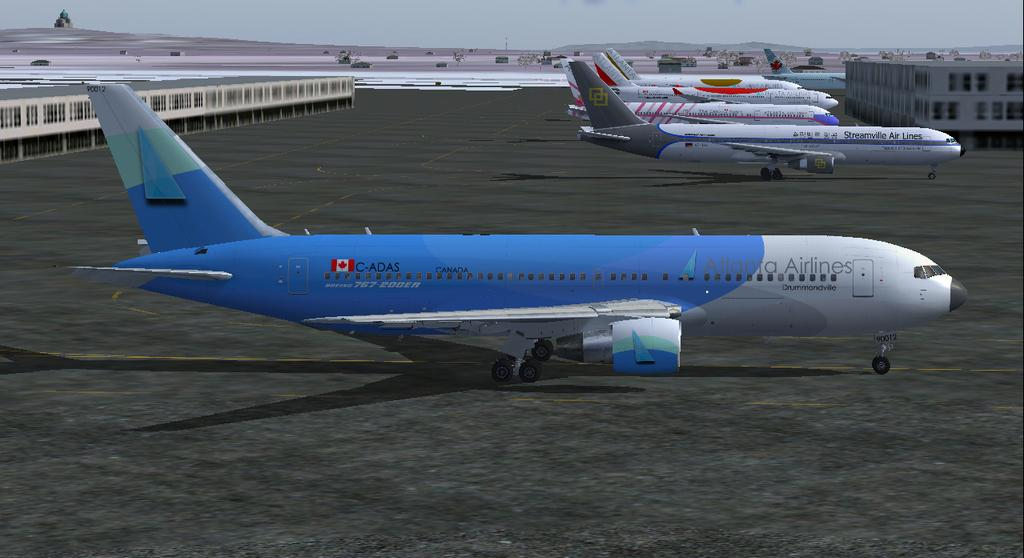What can be seen on the runway in the image? There are flights on the runway in the image. What type of structures are present in the image? There are buildings, a tower, and mountains visible in the image. What natural elements can be seen in the image? There are plants and stones visible in the image. What is visible in the sky in the image? The sky is visible in the image. What type of wire can be seen connecting the mountains in the image? There is no wire connecting the mountains in the image; only the mountains, buildings, plants, stones, and sky are present. What is the aftermath of the event depicted in the image? There is no event depicted in the image, as it shows a static scene of flights on the runway, buildings, mountains, plants, stones, and the sky. 